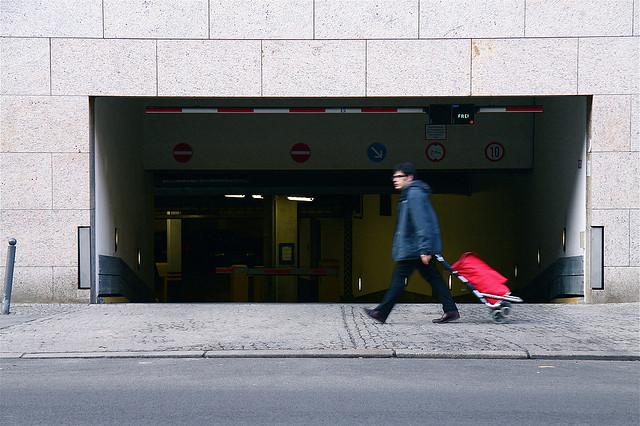How does he carry his luggage?
Write a very short answer. Pull. What color is the man's luggage?
Answer briefly. Red. What color are his pants?
Give a very brief answer. Black. 